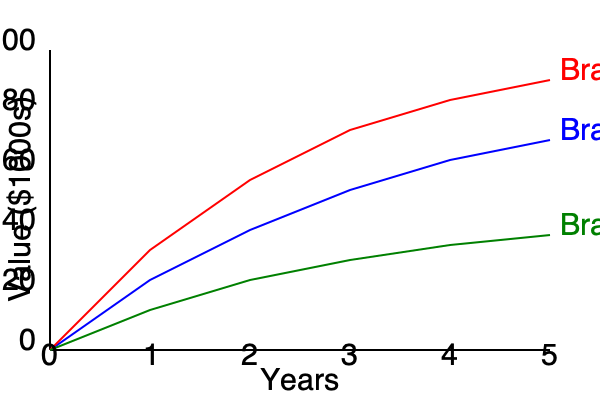Based on the depreciation rates shown in the line chart, which luxury car brand would be the best investment for someone who plans to sell their car after 3 years, assuming all brands have the same initial purchase price? To determine the best investment, we need to compare the depreciation rates of the three brands after 3 years:

1. Identify the values at the 3-year mark:
   Brand A: $52,000
   Brand B: $38,000
   Brand C: $74,000

2. Calculate the depreciation percentage for each brand:
   Initial value for all brands: $100,000

   Brand A: $(100,000 - 52,000) / 100,000 * 100 = 48%$ depreciation
   Brand B: $(100,000 - 38,000) / 100,000 * 100 = 62%$ depreciation
   Brand C: $(100,000 - 74,000) / 100,000 * 100 = 26%$ depreciation

3. Compare the depreciation percentages:
   Brand C has the lowest depreciation rate at 26%, followed by Brand A at 48%, and Brand B at 62%.

4. Conclusion:
   Brand C would be the best investment as it retains the highest value after 3 years, with only 26% depreciation.
Answer: Brand C 